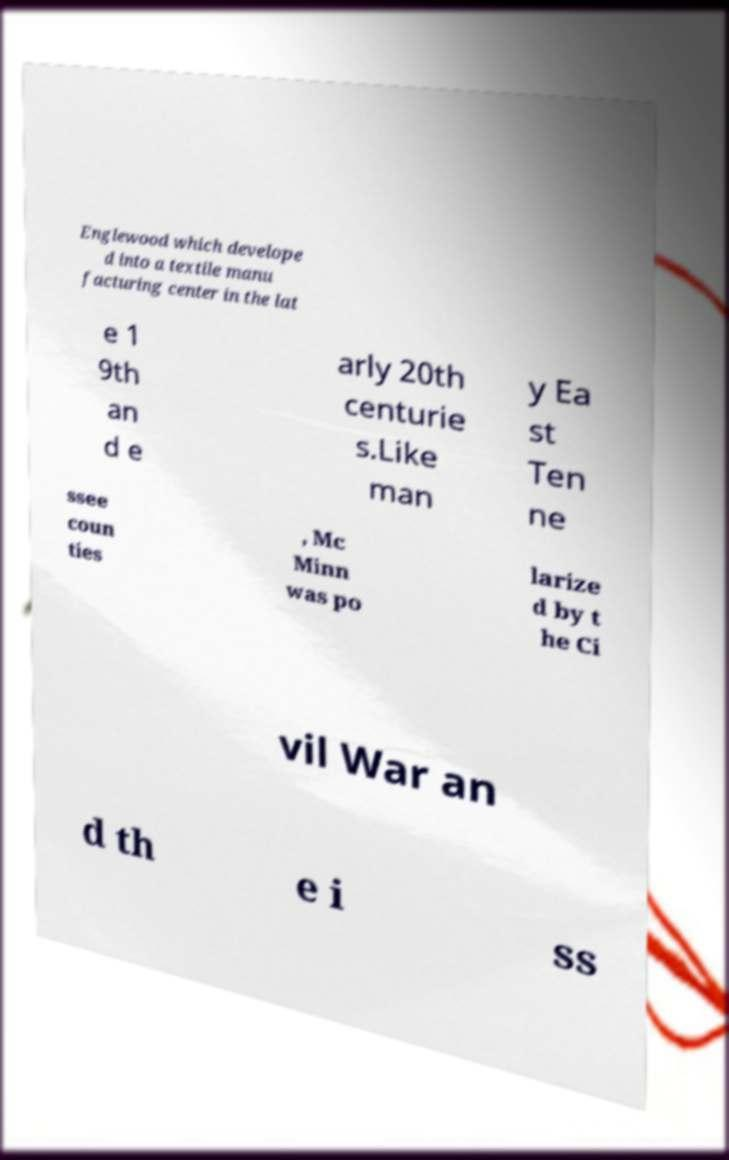Could you extract and type out the text from this image? Englewood which develope d into a textile manu facturing center in the lat e 1 9th an d e arly 20th centurie s.Like man y Ea st Ten ne ssee coun ties , Mc Minn was po larize d by t he Ci vil War an d th e i ss 